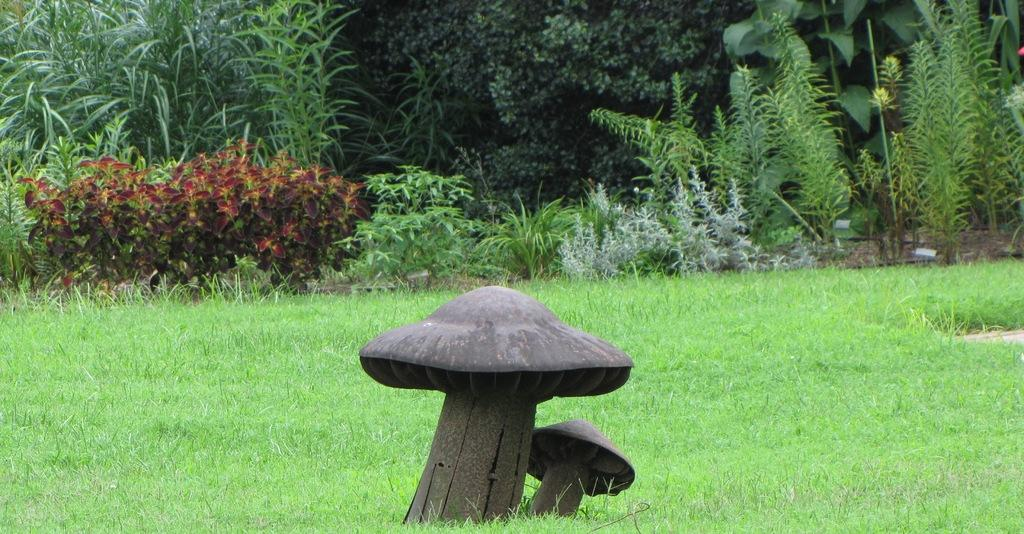What is the main subject in the image? There is a statue in the image. What can be seen in the background of the image? There are plants and trees in the background of the image. What type of patch is visible on the statue in the image? There is no patch visible on the statue in the image. What kind of print can be seen on the plants in the background? There is no print visible on the plants in the background; they are natural vegetation. 